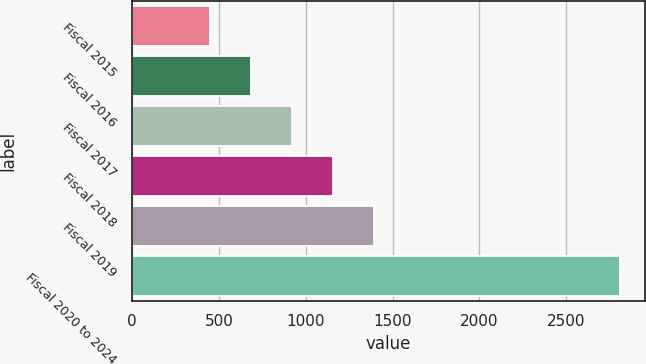Convert chart. <chart><loc_0><loc_0><loc_500><loc_500><bar_chart><fcel>Fiscal 2015<fcel>Fiscal 2016<fcel>Fiscal 2017<fcel>Fiscal 2018<fcel>Fiscal 2019<fcel>Fiscal 2020 to 2024<nl><fcel>451<fcel>686.9<fcel>922.8<fcel>1158.7<fcel>1394.6<fcel>2810<nl></chart> 